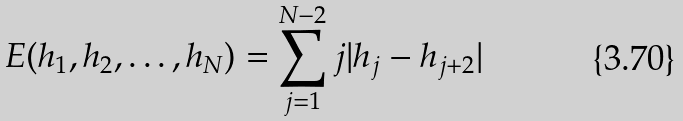Convert formula to latex. <formula><loc_0><loc_0><loc_500><loc_500>E ( h _ { 1 } , h _ { 2 } , \dots , h _ { N } ) = \sum _ { j = 1 } ^ { N - 2 } j | h _ { j } - h _ { j + 2 } |</formula> 